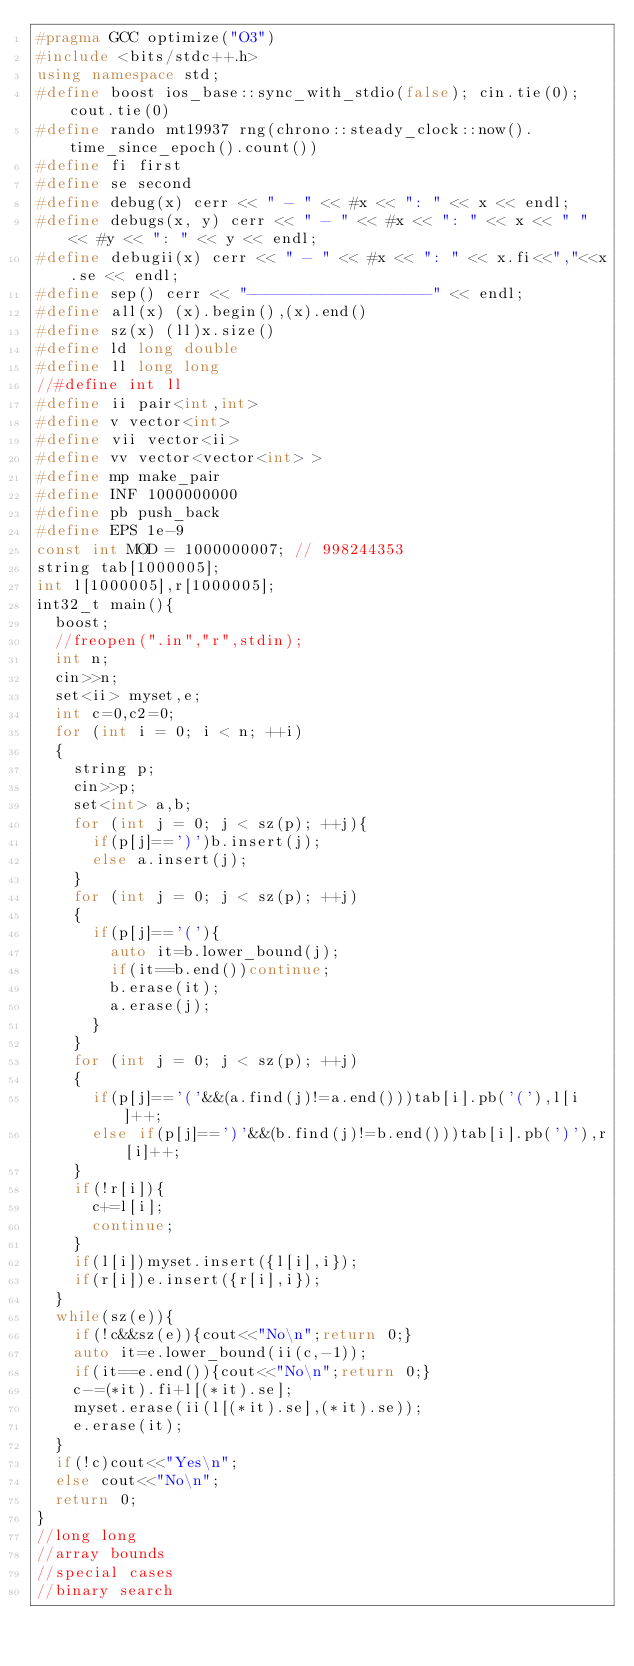Convert code to text. <code><loc_0><loc_0><loc_500><loc_500><_C++_>#pragma GCC optimize("O3")
#include <bits/stdc++.h>
using namespace std;
#define boost ios_base::sync_with_stdio(false); cin.tie(0); cout.tie(0)
#define rando mt19937 rng(chrono::steady_clock::now().time_since_epoch().count())
#define fi first
#define se second
#define debug(x) cerr << " - " << #x << ": " << x << endl;
#define debugs(x, y) cerr << " - " << #x << ": " << x << " " << #y << ": " << y << endl;
#define debugii(x) cerr << " - " << #x << ": " << x.fi<<","<<x.se << endl;
#define sep() cerr << "--------------------" << endl;
#define all(x) (x).begin(),(x).end()
#define sz(x) (ll)x.size()
#define ld long double
#define ll long long
//#define int ll
#define ii pair<int,int>
#define v vector<int>
#define vii vector<ii>
#define vv vector<vector<int> >
#define mp make_pair
#define INF 1000000000
#define pb push_back
#define EPS 1e-9
const int MOD = 1000000007; // 998244353
string tab[1000005];
int l[1000005],r[1000005];
int32_t main(){
	boost;
	//freopen(".in","r",stdin);
	int n;
	cin>>n;
	set<ii> myset,e;
	int c=0,c2=0;
	for (int i = 0; i < n; ++i)
	{
		string p;
		cin>>p;
		set<int> a,b;
		for (int j = 0; j < sz(p); ++j){
			if(p[j]==')')b.insert(j);
			else a.insert(j);
		}
		for (int j = 0; j < sz(p); ++j)
		{
			if(p[j]=='('){
				auto it=b.lower_bound(j);
				if(it==b.end())continue;
				b.erase(it);
				a.erase(j);
			}
		}
		for (int j = 0; j < sz(p); ++j)
		{
			if(p[j]=='('&&(a.find(j)!=a.end()))tab[i].pb('('),l[i]++;
			else if(p[j]==')'&&(b.find(j)!=b.end()))tab[i].pb(')'),r[i]++;
		}
		if(!r[i]){
			c+=l[i];
			continue;
		}
		if(l[i])myset.insert({l[i],i});
		if(r[i])e.insert({r[i],i});
	}
	while(sz(e)){
		if(!c&&sz(e)){cout<<"No\n";return 0;}
		auto it=e.lower_bound(ii(c,-1));
		if(it==e.end()){cout<<"No\n";return 0;}
		c-=(*it).fi+l[(*it).se];
		myset.erase(ii(l[(*it).se],(*it).se));
		e.erase(it);
	}
	if(!c)cout<<"Yes\n";
	else cout<<"No\n";
	return 0;
}
//long long
//array bounds
//special cases
//binary search</code> 